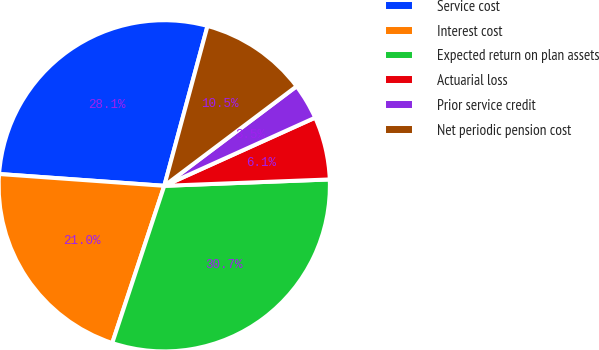<chart> <loc_0><loc_0><loc_500><loc_500><pie_chart><fcel>Service cost<fcel>Interest cost<fcel>Expected return on plan assets<fcel>Actuarial loss<fcel>Prior service credit<fcel>Net periodic pension cost<nl><fcel>28.07%<fcel>21.05%<fcel>30.7%<fcel>6.14%<fcel>3.51%<fcel>10.53%<nl></chart> 